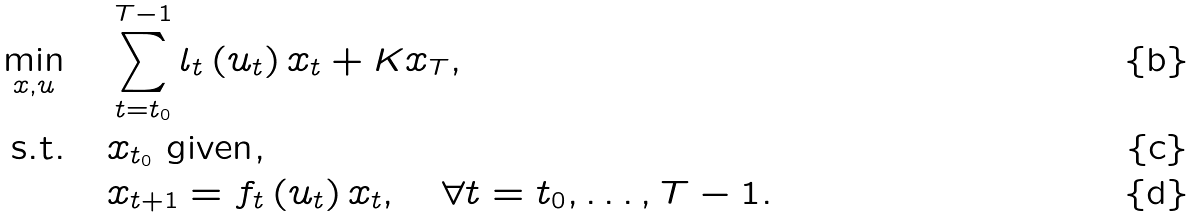Convert formula to latex. <formula><loc_0><loc_0><loc_500><loc_500>\min _ { x , u } \quad & \sum _ { t = t _ { 0 } } ^ { T - 1 } l _ { t } \left ( u _ { t } \right ) x _ { t } + K x _ { T } , \\ \text {s.t.} \quad & x _ { t _ { 0 } } \text { given} , \\ & x _ { t + 1 } = f _ { t } \left ( u _ { t } \right ) x _ { t } , \quad \forall t = t _ { 0 } , \dots , T - 1 .</formula> 